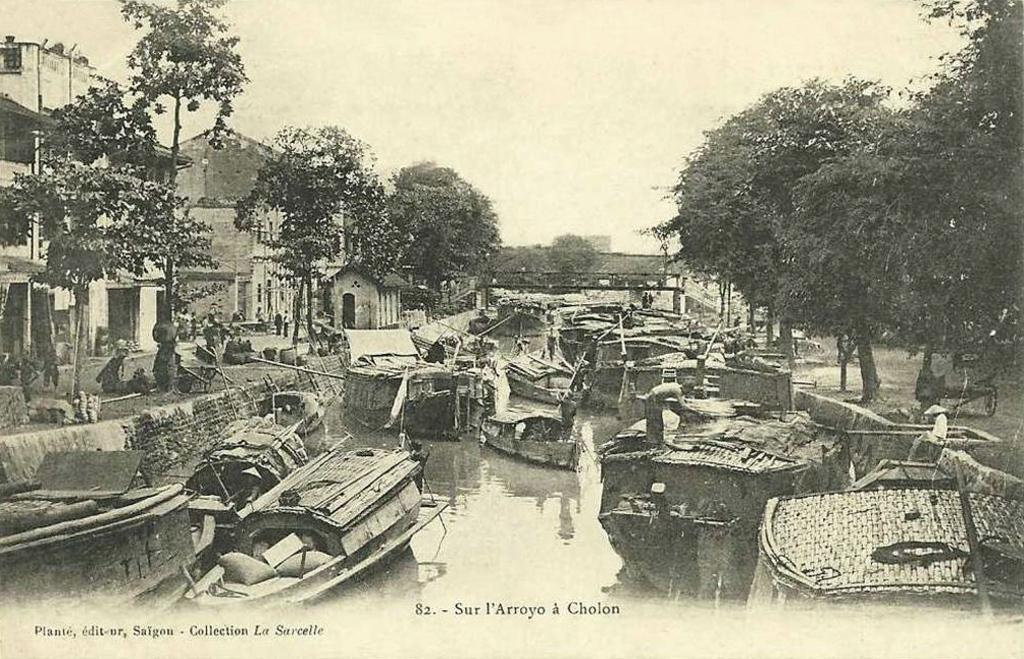What type of visual is the image? The image is a poster. What structures can be seen in the image? There are buildings in the image. What type of natural elements are present in the image? There are trees and water in the image. What man-made objects are visible in the image? There are boards in the image. Are there any living beings in the image? Yes, there are people in the image. What else can be found in the image? There are objects in the image. Is there any text present in the image? Yes, there is text written at the bottom portion of the image. What type of humor can be found in the image? There is no humor present in the image; it is a poster featuring buildings, trees, water, boards, people, objects, and text. 